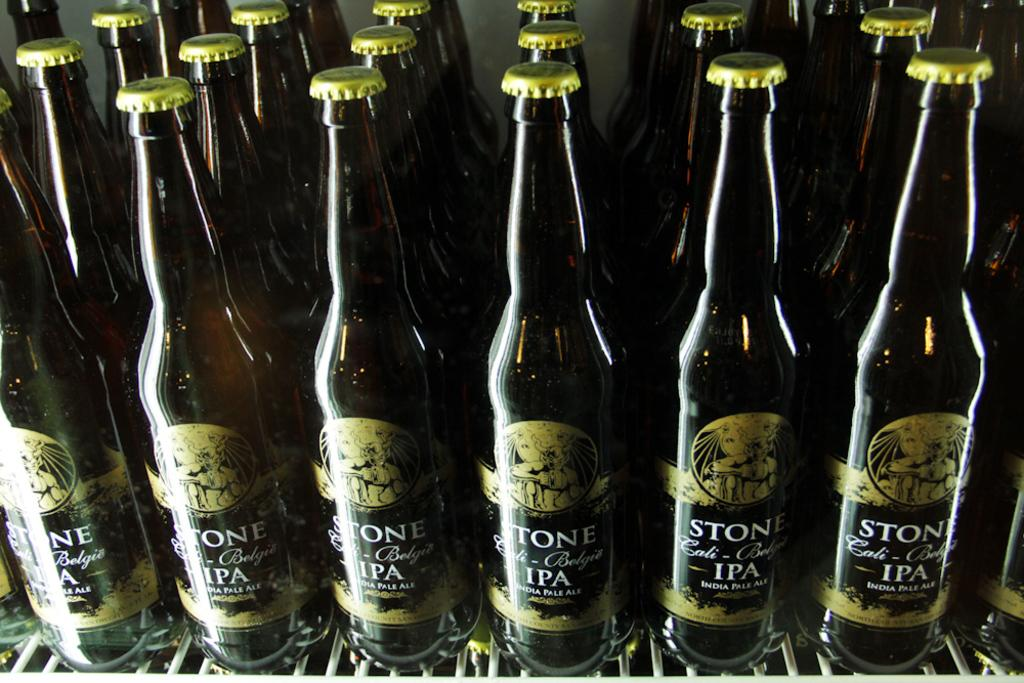<image>
Describe the image concisely. the word stone is on many of the beer bottles 